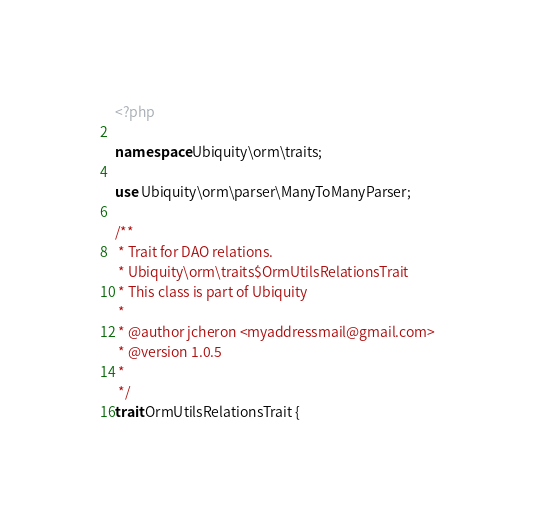<code> <loc_0><loc_0><loc_500><loc_500><_PHP_><?php

namespace Ubiquity\orm\traits;

use Ubiquity\orm\parser\ManyToManyParser;

/**
 * Trait for DAO relations.
 * Ubiquity\orm\traits$OrmUtilsRelationsTrait
 * This class is part of Ubiquity
 *
 * @author jcheron <myaddressmail@gmail.com>
 * @version 1.0.5
 *
 */
trait OrmUtilsRelationsTrait {
</code> 